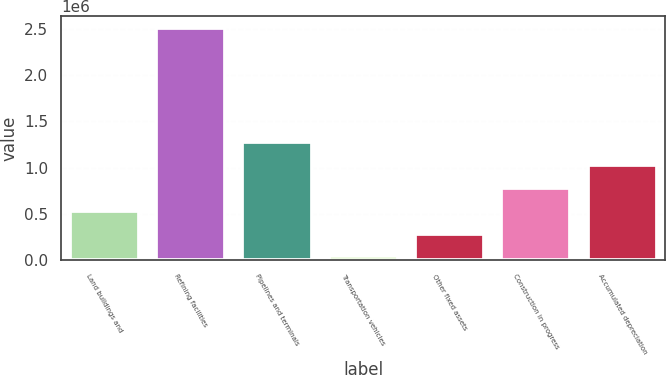Convert chart. <chart><loc_0><loc_0><loc_500><loc_500><bar_chart><fcel>Land buildings and<fcel>Refining facilities<fcel>Pipelines and terminals<fcel>Transportation vehicles<fcel>Other fixed assets<fcel>Construction in progress<fcel>Accumulated depreciation<nl><fcel>535003<fcel>2.51075e+06<fcel>1.27591e+06<fcel>41066<fcel>288034<fcel>781971<fcel>1.02894e+06<nl></chart> 